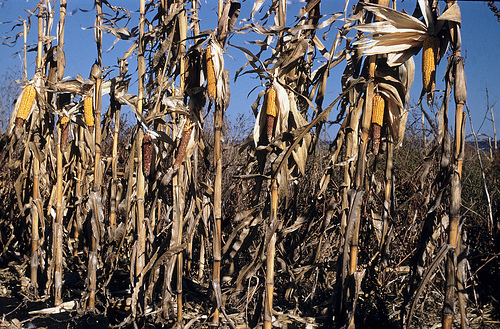<image>
Is the corn in front of the ground? No. The corn is not in front of the ground. The spatial positioning shows a different relationship between these objects. 